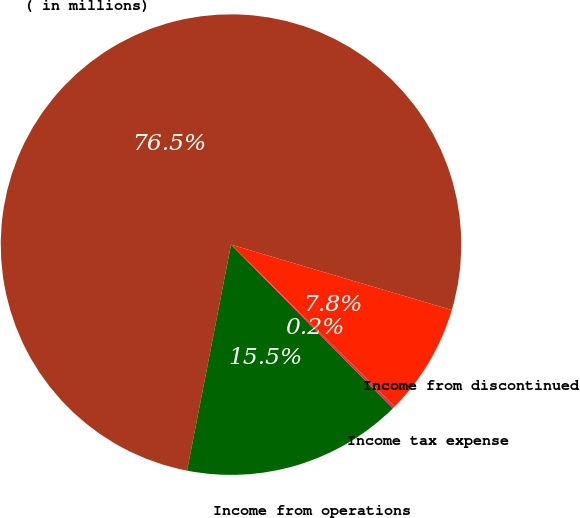Convert chart. <chart><loc_0><loc_0><loc_500><loc_500><pie_chart><fcel>( in millions)<fcel>Income from operations<fcel>Income tax expense<fcel>Income from discontinued<nl><fcel>76.53%<fcel>15.46%<fcel>0.19%<fcel>7.82%<nl></chart> 